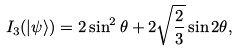Convert formula to latex. <formula><loc_0><loc_0><loc_500><loc_500>I _ { 3 } ( | \psi \rangle ) = 2 \sin ^ { 2 } \theta + 2 \sqrt { \frac { 2 } { 3 } } \sin 2 \theta ,</formula> 